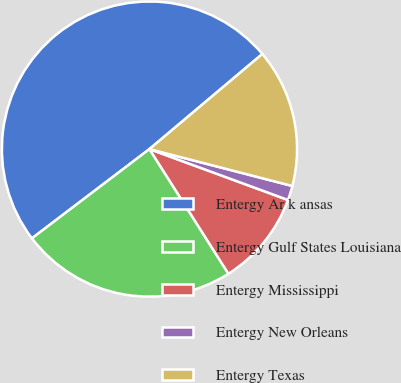Convert chart to OTSL. <chart><loc_0><loc_0><loc_500><loc_500><pie_chart><fcel>Entergy Ar k ansas<fcel>Entergy Gulf States Louisiana<fcel>Entergy Mississippi<fcel>Entergy New Orleans<fcel>Entergy Texas<nl><fcel>49.2%<fcel>23.65%<fcel>10.41%<fcel>1.58%<fcel>15.17%<nl></chart> 